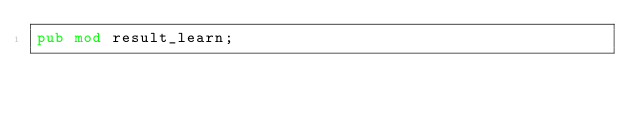<code> <loc_0><loc_0><loc_500><loc_500><_Rust_>pub mod result_learn;
</code> 